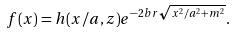<formula> <loc_0><loc_0><loc_500><loc_500>f ( x ) = h ( x / a , z ) e ^ { - 2 b r \sqrt { x ^ { 2 } / a ^ { 2 } + m ^ { 2 } } } .</formula> 